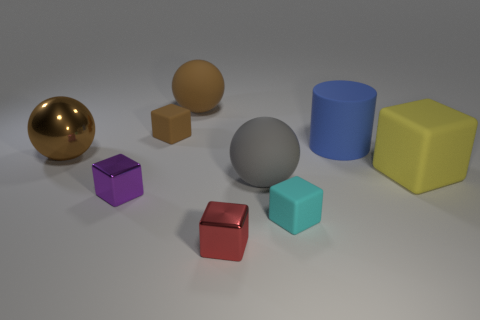There is a purple metal object that is the same size as the cyan thing; what is its shape?
Offer a terse response. Cube. How many tiny metallic cubes are to the left of the large matte sphere that is behind the large blue cylinder behind the gray matte object?
Keep it short and to the point. 1. How many metallic things are either small green blocks or tiny red objects?
Your response must be concise. 1. What color is the rubber thing that is to the right of the tiny brown rubber thing and behind the big blue object?
Ensure brevity in your answer.  Brown. There is a block in front of the cyan matte cube; is it the same size as the big brown shiny ball?
Give a very brief answer. No. What number of objects are either cubes that are on the right side of the cyan matte thing or small red metallic blocks?
Provide a short and direct response. 2. Are there any other blue matte cylinders that have the same size as the blue cylinder?
Offer a terse response. No. What is the material of the yellow object that is the same size as the gray thing?
Keep it short and to the point. Rubber. What shape is the object that is both behind the brown shiny ball and right of the gray rubber object?
Your answer should be very brief. Cylinder. What color is the cube on the right side of the small cyan rubber object?
Give a very brief answer. Yellow. 